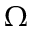Convert formula to latex. <formula><loc_0><loc_0><loc_500><loc_500>\Omega \,</formula> 